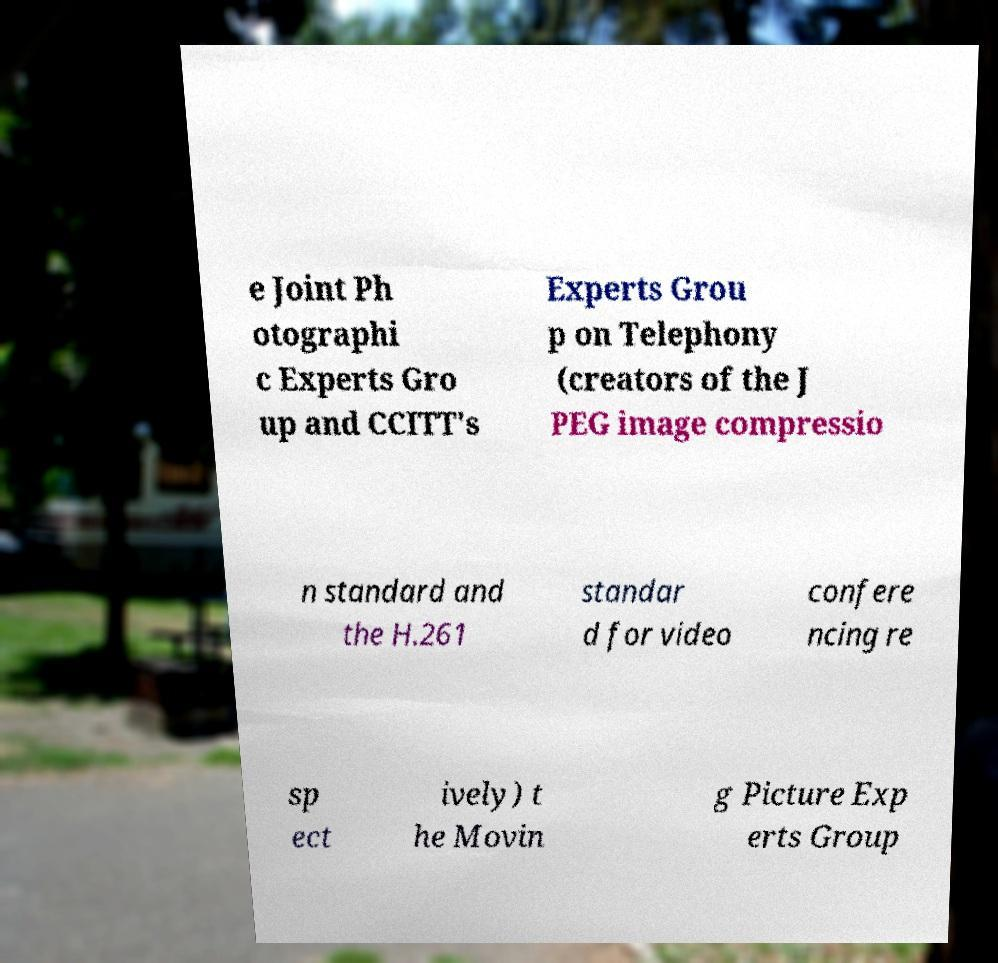Could you extract and type out the text from this image? e Joint Ph otographi c Experts Gro up and CCITT's Experts Grou p on Telephony (creators of the J PEG image compressio n standard and the H.261 standar d for video confere ncing re sp ect ively) t he Movin g Picture Exp erts Group 